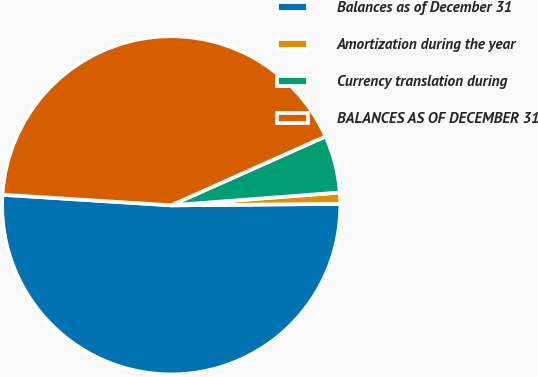Convert chart to OTSL. <chart><loc_0><loc_0><loc_500><loc_500><pie_chart><fcel>Balances as of December 31<fcel>Amortization during the year<fcel>Currency translation during<fcel>BALANCES AS OF DECEMBER 31<nl><fcel>51.14%<fcel>1.07%<fcel>5.48%<fcel>42.32%<nl></chart> 